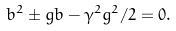Convert formula to latex. <formula><loc_0><loc_0><loc_500><loc_500>b ^ { 2 } \pm g b - \gamma ^ { 2 } g ^ { 2 } / 2 = 0 .</formula> 